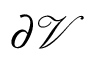<formula> <loc_0><loc_0><loc_500><loc_500>\partial \mathcal { V }</formula> 